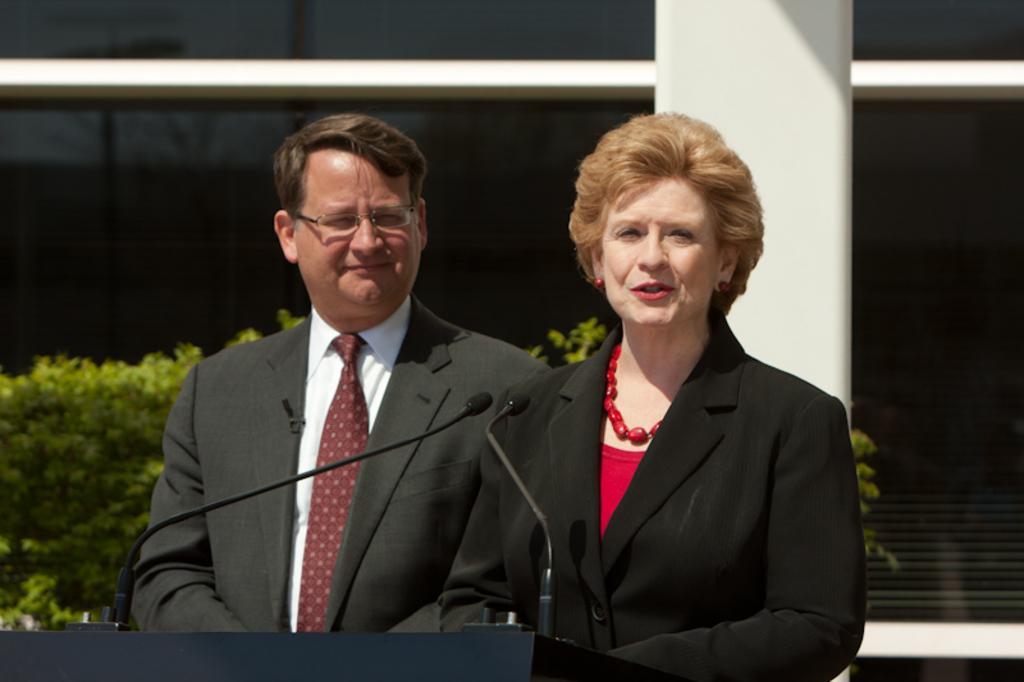In one or two sentences, can you explain what this image depicts? In this picture we can see a man and a woman, a woman is standing in front of a podium, we can see two microphones on the podium, in the background there is a building, we can see shrubs on the left side, this man wore spectacles. 